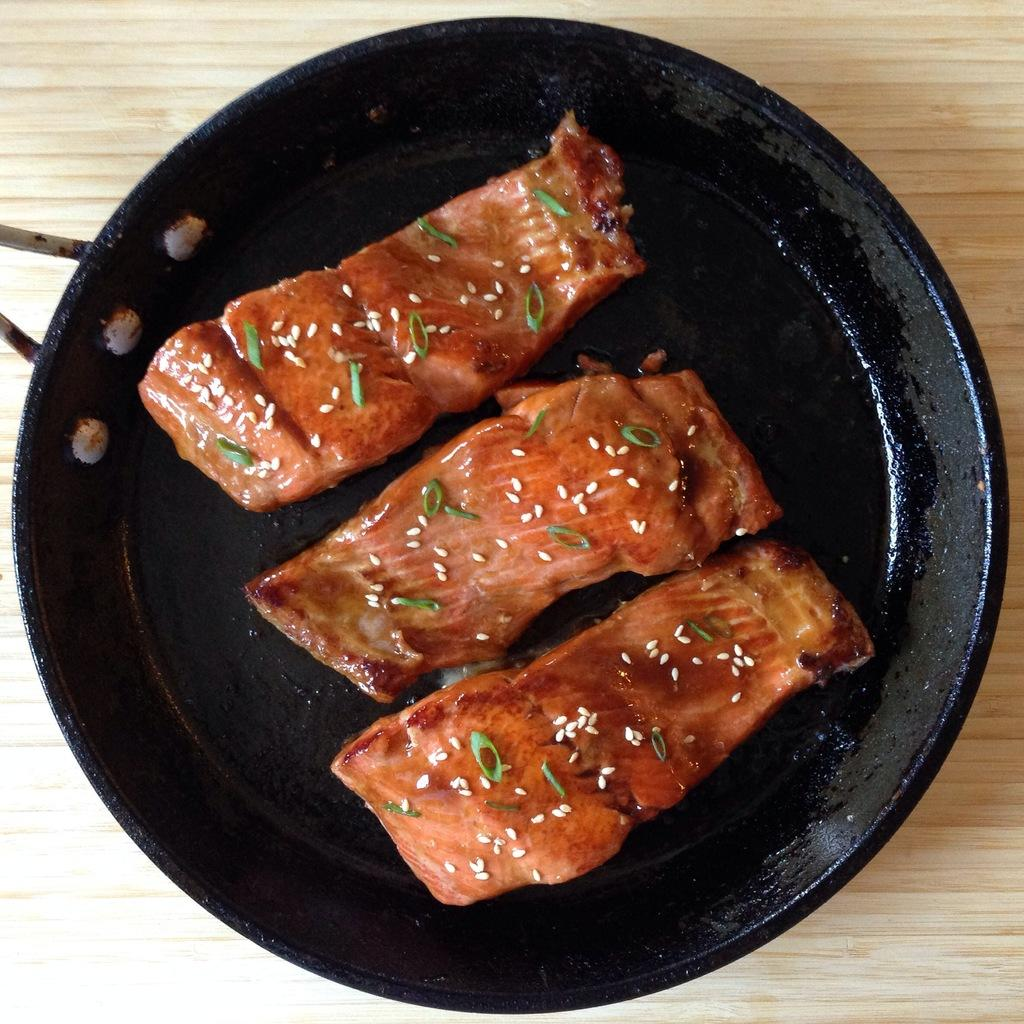What is in the pan that is visible in the image? There is a food item in a pan. What is the pan placed on in the image? The pan is on a wooden board. What day of the week is depicted in the image? There is no indication of a specific day of the week in the image. What type of pet can be seen interacting with the food item in the pan? There is no pet present in the image. What type of rock formation is visible in the background of the image? There is no rock formation visible in the image; it only features a food item in a pan on a wooden board. 